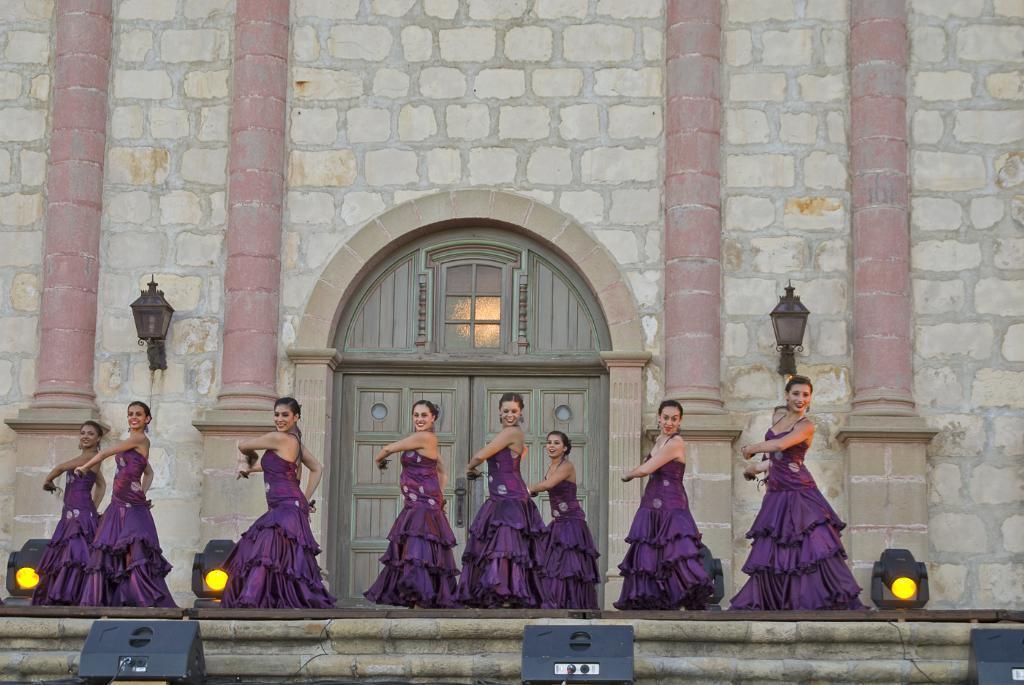Could you give a brief overview of what you see in this image? In this image I can see the group of people wearing the purple color dresses. In the background I can see the lights and door to the wall. I can also see the light to the side. 